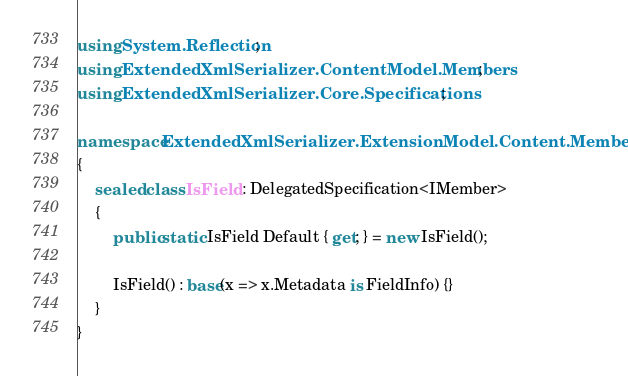<code> <loc_0><loc_0><loc_500><loc_500><_C#_>using System.Reflection;
using ExtendedXmlSerializer.ContentModel.Members;
using ExtendedXmlSerializer.Core.Specifications;

namespace ExtendedXmlSerializer.ExtensionModel.Content.Members
{
	sealed class IsField : DelegatedSpecification<IMember>
	{
		public static IsField Default { get; } = new IsField();

		IsField() : base(x => x.Metadata is FieldInfo) {}
	}
}</code> 